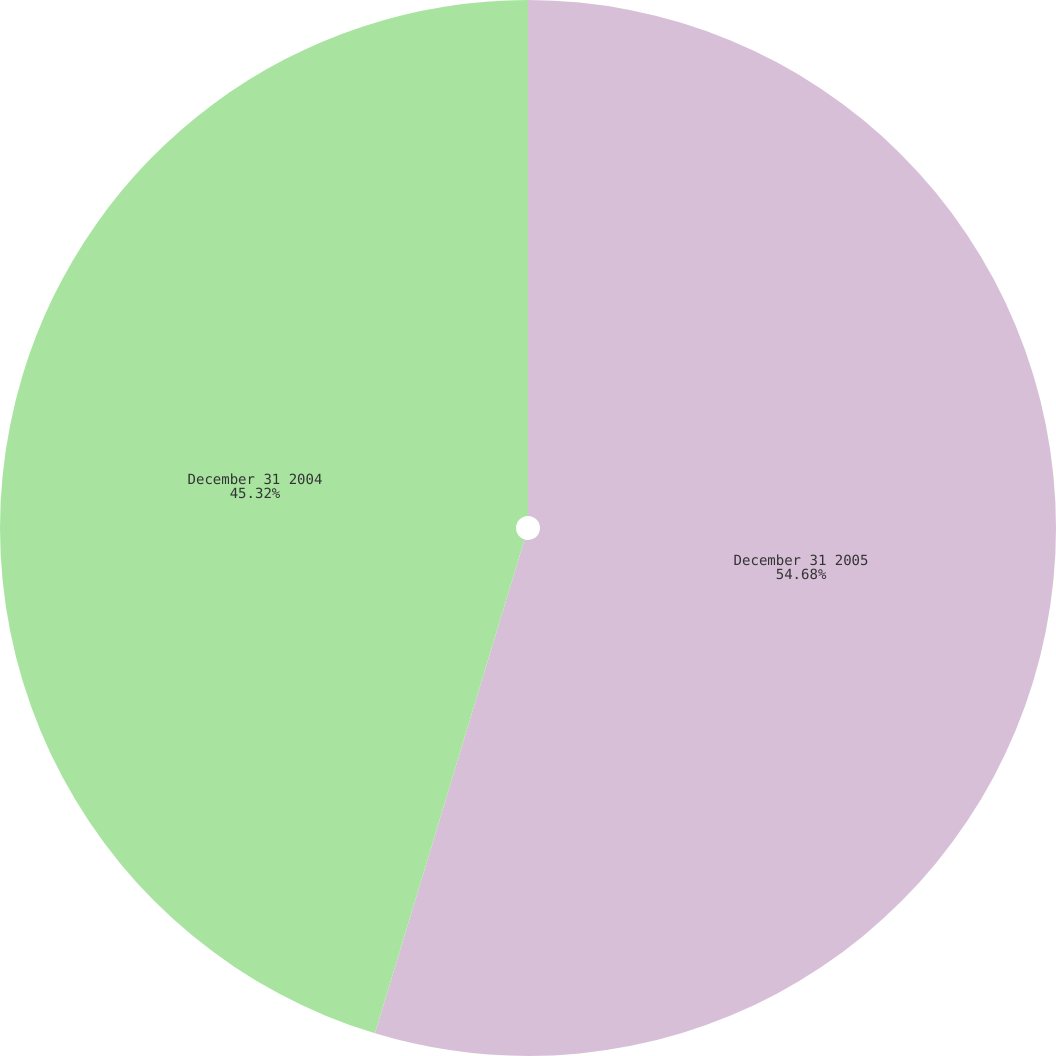<chart> <loc_0><loc_0><loc_500><loc_500><pie_chart><fcel>December 31 2005<fcel>December 31 2004<nl><fcel>54.68%<fcel>45.32%<nl></chart> 